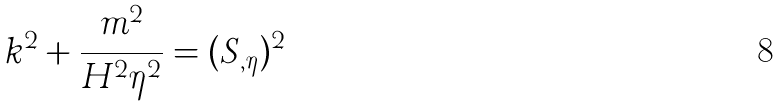Convert formula to latex. <formula><loc_0><loc_0><loc_500><loc_500>k ^ { 2 } + \frac { m ^ { 2 } } { H ^ { 2 } \eta ^ { 2 } } = ( S _ { , \eta } ) ^ { 2 }</formula> 